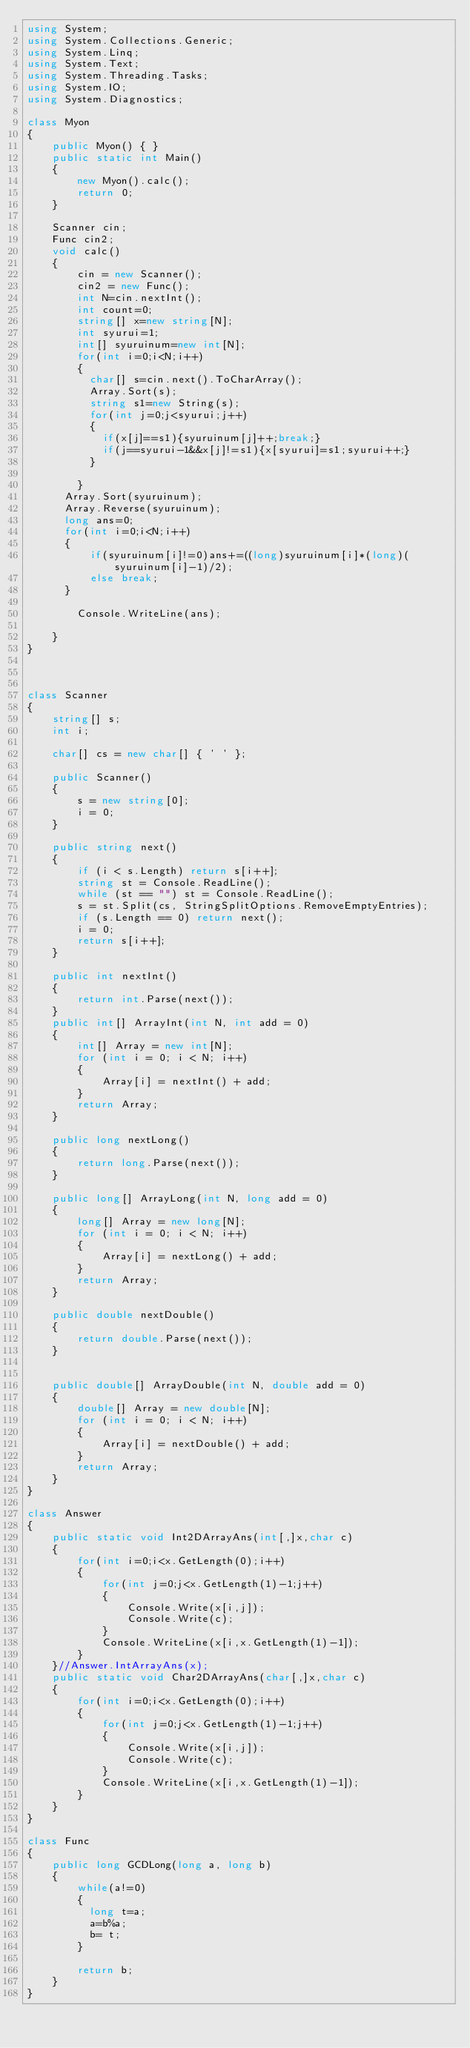<code> <loc_0><loc_0><loc_500><loc_500><_C#_>using System;
using System.Collections.Generic;
using System.Linq;
using System.Text;
using System.Threading.Tasks;
using System.IO;
using System.Diagnostics;

class Myon
{
    public Myon() { }
    public static int Main()
    {
        new Myon().calc();
        return 0;
    }

    Scanner cin;
    Func cin2;
    void calc()
    {
        cin = new Scanner();
        cin2 = new Func();
        int N=cin.nextInt();
        int count=0;
        string[] x=new string[N];
        int syurui=1;
        int[] syuruinum=new int[N];
        for(int i=0;i<N;i++)
        {
          char[] s=cin.next().ToCharArray();
          Array.Sort(s);
          string s1=new String(s);
          for(int j=0;j<syurui;j++)
          {
            if(x[j]==s1){syuruinum[j]++;break;}
            if(j==syurui-1&&x[j]!=s1){x[syurui]=s1;syurui++;}
          }
          
        }
      Array.Sort(syuruinum);
      Array.Reverse(syuruinum);
      long ans=0;
      for(int i=0;i<N;i++)
      {
          if(syuruinum[i]!=0)ans+=((long)syuruinum[i]*(long)(syuruinum[i]-1)/2);
          else break;
      }
        
        Console.WriteLine(ans);
        
    }
}



class Scanner
{
    string[] s;
    int i;

    char[] cs = new char[] { ' ' };

    public Scanner()
    {
        s = new string[0];
        i = 0;
    }

    public string next()
    {
        if (i < s.Length) return s[i++];
        string st = Console.ReadLine();
        while (st == "") st = Console.ReadLine();
        s = st.Split(cs, StringSplitOptions.RemoveEmptyEntries);
        if (s.Length == 0) return next();
        i = 0;
        return s[i++];
    }

    public int nextInt()
    {
        return int.Parse(next());
    }
    public int[] ArrayInt(int N, int add = 0)
    {
        int[] Array = new int[N];
        for (int i = 0; i < N; i++)
        {
            Array[i] = nextInt() + add;
        }
        return Array;
    }

    public long nextLong()
    {
        return long.Parse(next());
    }

    public long[] ArrayLong(int N, long add = 0)
    {
        long[] Array = new long[N];
        for (int i = 0; i < N; i++)
        {
            Array[i] = nextLong() + add;
        }
        return Array;
    }

    public double nextDouble()
    {
        return double.Parse(next());
    }


    public double[] ArrayDouble(int N, double add = 0)
    {
        double[] Array = new double[N];
        for (int i = 0; i < N; i++)
        {
            Array[i] = nextDouble() + add;
        }
        return Array;
    }
}

class Answer
{
    public static void Int2DArrayAns(int[,]x,char c)
    {
        for(int i=0;i<x.GetLength(0);i++)
        {
            for(int j=0;j<x.GetLength(1)-1;j++)
            {
                Console.Write(x[i,j]);
                Console.Write(c);
            }
            Console.WriteLine(x[i,x.GetLength(1)-1]);
        }
    }//Answer.IntArrayAns(x);
    public static void Char2DArrayAns(char[,]x,char c)
    {
        for(int i=0;i<x.GetLength(0);i++)
        {
            for(int j=0;j<x.GetLength(1)-1;j++)
            {
                Console.Write(x[i,j]);
                Console.Write(c);
            }
            Console.WriteLine(x[i,x.GetLength(1)-1]);
        }
    }
}

class Func
{
    public long GCDLong(long a, long b)
    {
        while(a!=0)
        {
          long t=a;
          a=b%a;
          b= t;
        }
      
        return b;        
    }
}
</code> 